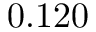<formula> <loc_0><loc_0><loc_500><loc_500>0 . 1 2 0</formula> 